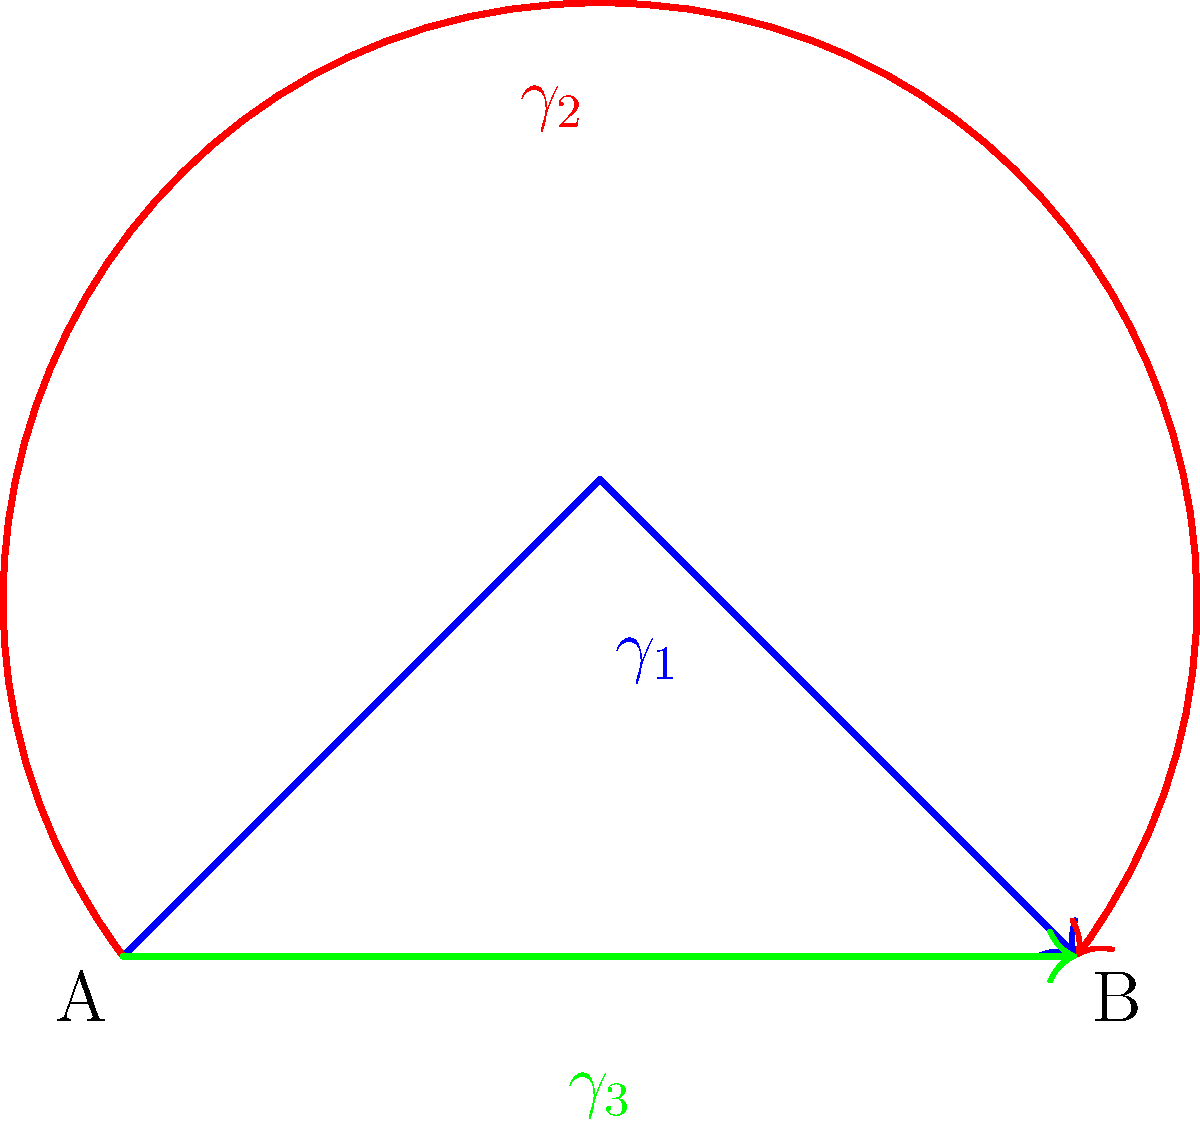Consider the topological space $X$ representing the paths of three notable women military leaders throughout history, as shown in the diagram. The paths $\gamma_1$, $\gamma_2$, and $\gamma_3$ connect points A and B. What is the genus of this topological space? To determine the genus of this topological space, we need to follow these steps:

1. Identify the type of topological space:
   The space consists of three paths connecting two points, forming a closed loop.

2. Recognize the fundamental group:
   The fundamental group of this space is isomorphic to the free group on two generators, as there are three paths but only two independent loops.

3. Apply the Seifert-van Kampen theorem:
   This theorem allows us to compute the fundamental group of a space by decomposing it into simpler subspaces.

4. Relate the fundamental group to the genus:
   For a closed orientable surface, the genus $g$ is related to the rank of the fundamental group by the formula:
   $$\text{rank}(\pi_1(X)) = 2g$$

5. Determine the rank of the fundamental group:
   The rank of the free group on two generators is 2.

6. Calculate the genus:
   Using the formula from step 4:
   $$2 = 2g$$
   $$g = 1$$

Therefore, the genus of this topological space is 1.
Answer: 1 